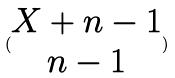<formula> <loc_0><loc_0><loc_500><loc_500>( \begin{matrix} X + n - 1 \\ n - 1 \end{matrix} )</formula> 